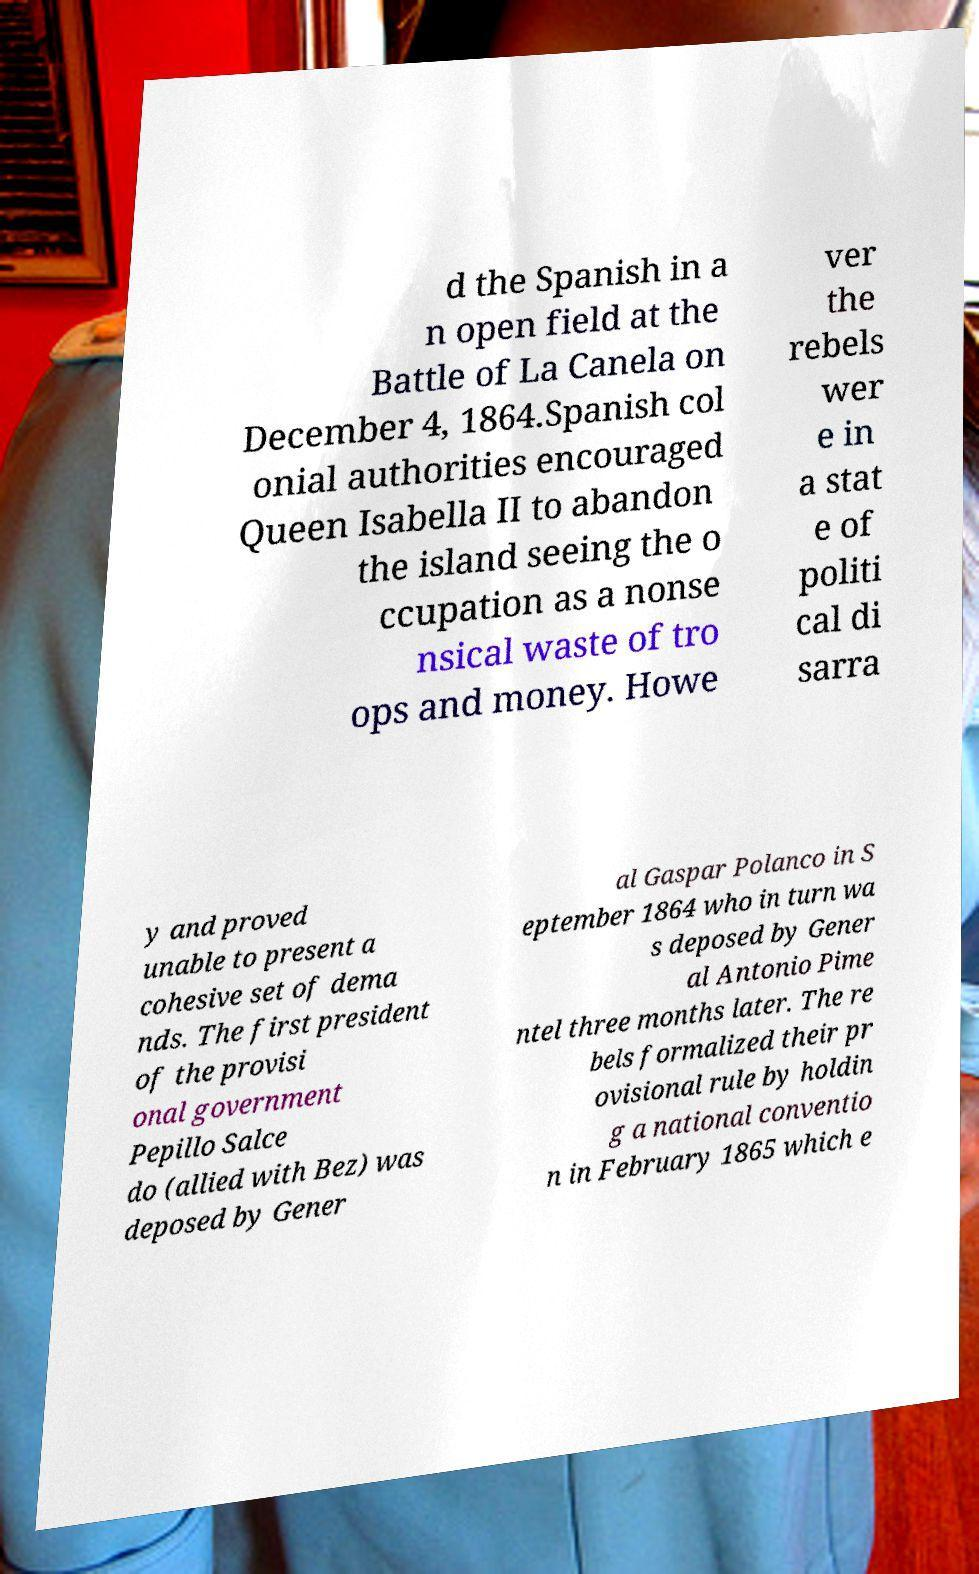Could you assist in decoding the text presented in this image and type it out clearly? d the Spanish in a n open field at the Battle of La Canela on December 4, 1864.Spanish col onial authorities encouraged Queen Isabella II to abandon the island seeing the o ccupation as a nonse nsical waste of tro ops and money. Howe ver the rebels wer e in a stat e of politi cal di sarra y and proved unable to present a cohesive set of dema nds. The first president of the provisi onal government Pepillo Salce do (allied with Bez) was deposed by Gener al Gaspar Polanco in S eptember 1864 who in turn wa s deposed by Gener al Antonio Pime ntel three months later. The re bels formalized their pr ovisional rule by holdin g a national conventio n in February 1865 which e 